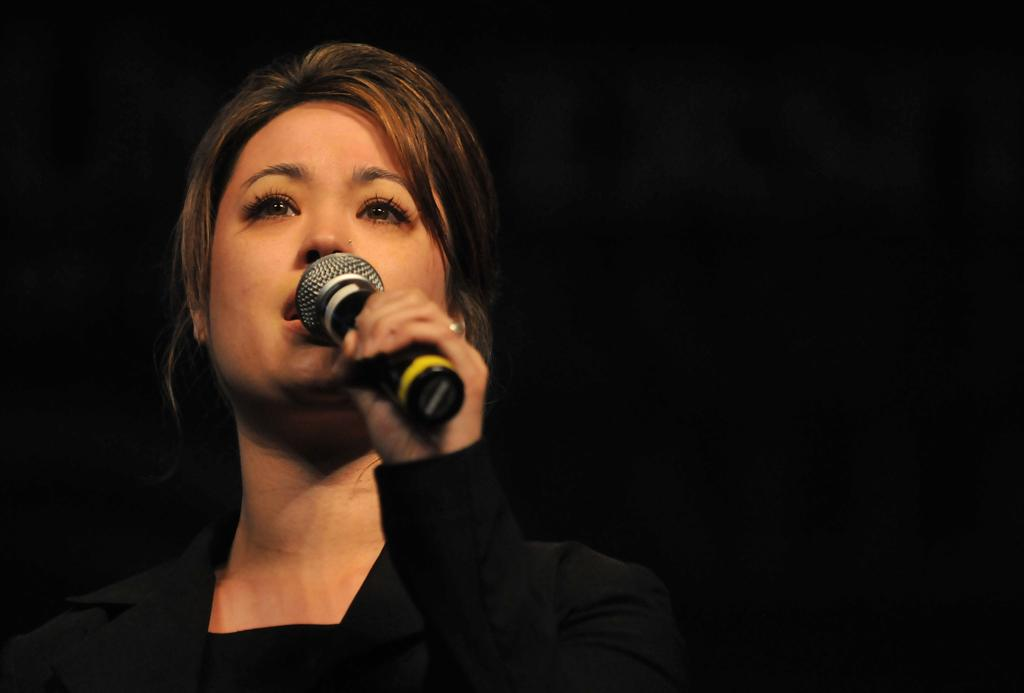What is the main subject of the image? There is a person in the image. What is the person holding in the image? The person is holding a microphone. What is the person wearing in the image? The person is wearing a black dress. What type of cream can be seen on the person's muscles in the image? There is no cream or muscles visible on the person in the image; they are wearing a black dress and holding a microphone. 